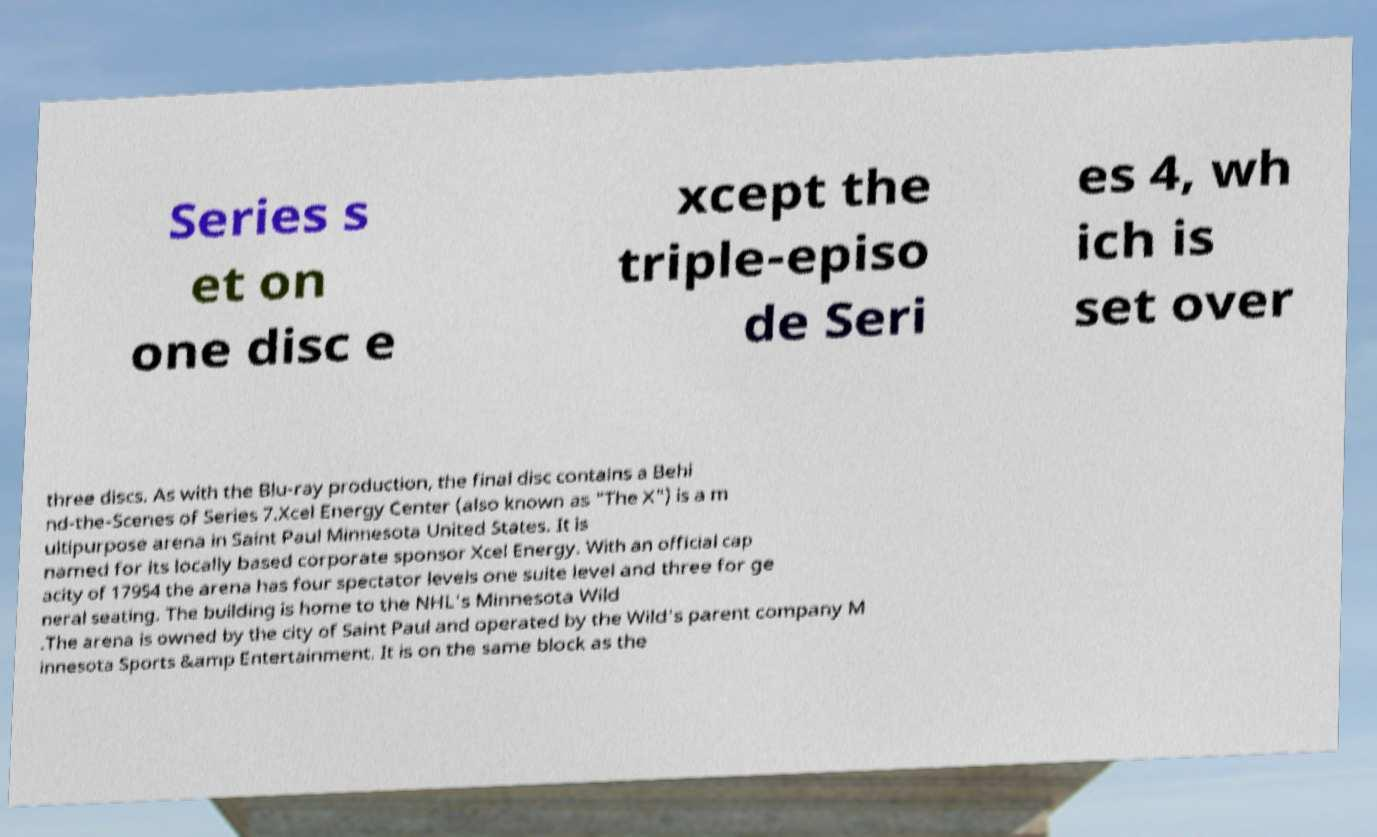Could you assist in decoding the text presented in this image and type it out clearly? Series s et on one disc e xcept the triple-episo de Seri es 4, wh ich is set over three discs. As with the Blu-ray production, the final disc contains a Behi nd-the-Scenes of Series 7.Xcel Energy Center (also known as "The X") is a m ultipurpose arena in Saint Paul Minnesota United States. It is named for its locally based corporate sponsor Xcel Energy. With an official cap acity of 17954 the arena has four spectator levels one suite level and three for ge neral seating. The building is home to the NHL's Minnesota Wild .The arena is owned by the city of Saint Paul and operated by the Wild's parent company M innesota Sports &amp Entertainment. It is on the same block as the 